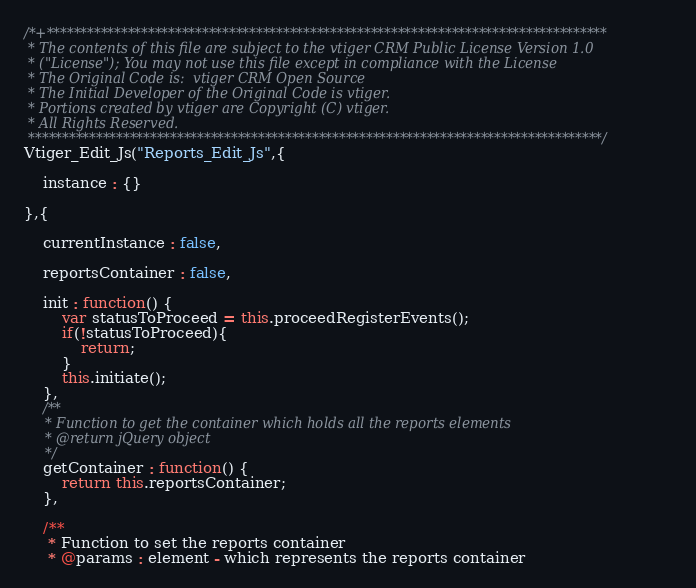<code> <loc_0><loc_0><loc_500><loc_500><_JavaScript_>/*+***********************************************************************************
 * The contents of this file are subject to the vtiger CRM Public License Version 1.0
 * ("License"); You may not use this file except in compliance with the License
 * The Original Code is:  vtiger CRM Open Source
 * The Initial Developer of the Original Code is vtiger.
 * Portions created by vtiger are Copyright (C) vtiger.
 * All Rights Reserved.
 *************************************************************************************/
Vtiger_Edit_Js("Reports_Edit_Js",{
	
	instance : {}
	
},{
	
	currentInstance : false,
	
	reportsContainer : false,
	
	init : function() {
		var statusToProceed = this.proceedRegisterEvents();
		if(!statusToProceed){
			return;
		}
		this.initiate();
	},
	/**
	 * Function to get the container which holds all the reports elements
	 * @return jQuery object
	 */
	getContainer : function() {
		return this.reportsContainer;
	},

	/**
	 * Function to set the reports container
	 * @params : element - which represents the reports container</code> 